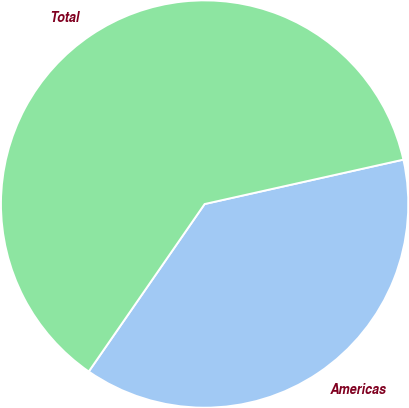<chart> <loc_0><loc_0><loc_500><loc_500><pie_chart><fcel>Americas<fcel>Total<nl><fcel>38.13%<fcel>61.87%<nl></chart> 